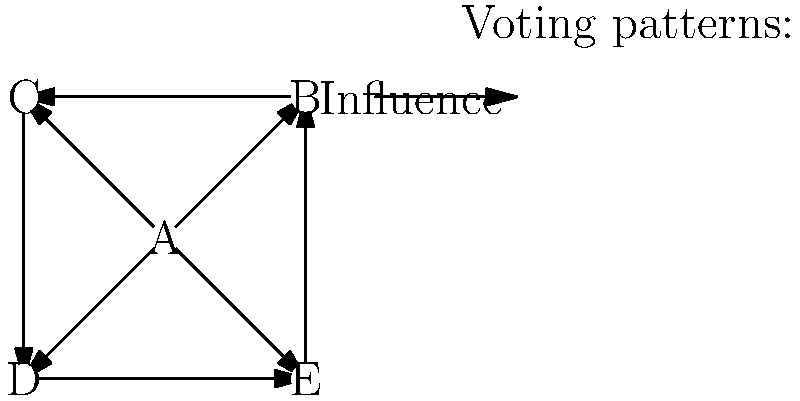In the network graph representing parliamentary voting patterns, which node appears to have the highest centrality, potentially indicating the most influential member or party in the voting process? To determine the node with the highest centrality in this network graph, we need to analyze the connections and their directions:

1. Count the number of outgoing edges (influence exerted) for each node:
   Node A: 4 outgoing edges
   Nodes B, C, D, E: 1 outgoing edge each

2. Count the number of incoming edges (influence received) for each node:
   Node A: 0 incoming edges
   Nodes B, C, D, E: 2 incoming edges each

3. Calculate the total degree (outgoing + incoming) for each node:
   Node A: 4 + 0 = 4
   Nodes B, C, D, E: 1 + 2 = 3 each

4. Analyze the centrality:
   - Node A has the highest out-degree centrality (4 outgoing edges)
   - Node A has the highest total degree centrality (4 total connections)
   - Node A is the only node with no incoming edges, indicating it's not influenced by others

5. Interpret the results:
   Node A appears to have the highest centrality in the network, as it influences all other nodes directly and is not influenced by any other node. This suggests that Node A represents the most influential member or party in the voting process.
Answer: Node A 